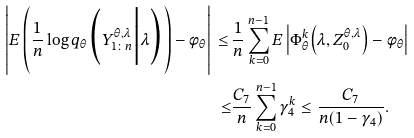<formula> <loc_0><loc_0><loc_500><loc_500>\left | E \left ( \frac { 1 } { n } \log q _ { \theta } \Big ( Y _ { 1 \colon n } ^ { \theta , \lambda } \Big | \lambda \Big ) \right ) - \phi _ { \theta } \right | \, \leq \, & \frac { 1 } { n } \sum _ { k = 0 } ^ { n - 1 } E \left | \Phi _ { \theta } ^ { k } \Big ( \lambda , Z _ { 0 } ^ { \theta , \lambda } \Big ) - \phi _ { \theta } \right | \\ \leq & \frac { C _ { 7 } } { n } \sum _ { k = 0 } ^ { n - 1 } \gamma _ { 4 } ^ { k } \leq \frac { C _ { 7 } } { n ( 1 - \gamma _ { 4 } ) } .</formula> 